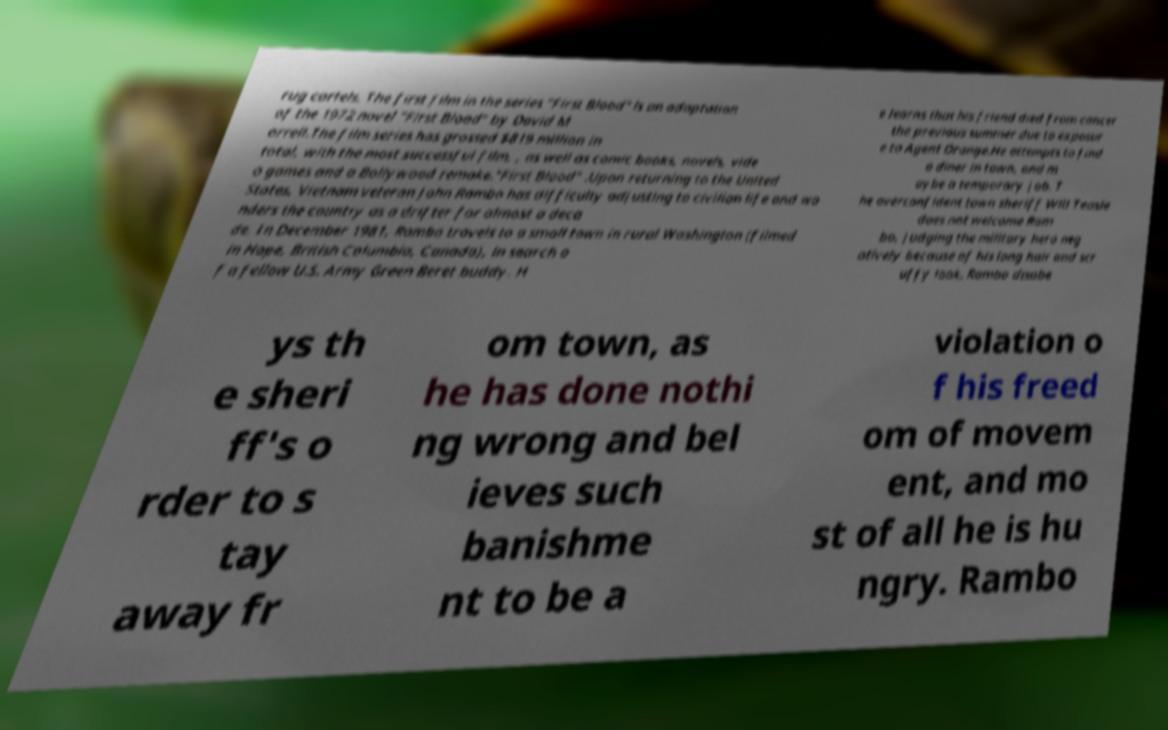I need the written content from this picture converted into text. Can you do that? rug cartels. The first film in the series "First Blood" is an adaptation of the 1972 novel "First Blood" by David M orrell.The film series has grossed $819 million in total, with the most successful film, , as well as comic books, novels, vide o games and a Bollywood remake."First Blood" .Upon returning to the United States, Vietnam veteran John Rambo has difficulty adjusting to civilian life and wa nders the country as a drifter for almost a deca de. In December 1981, Rambo travels to a small town in rural Washington (filmed in Hope, British Columbia, Canada), in search o f a fellow U.S. Army Green Beret buddy. H e learns that his friend died from cancer the previous summer due to exposur e to Agent Orange.He attempts to find a diner in town, and m aybe a temporary job. T he overconfident town sheriff Will Teasle does not welcome Ram bo, judging the military hero neg atively because of his long hair and scr uffy look. Rambo disobe ys th e sheri ff's o rder to s tay away fr om town, as he has done nothi ng wrong and bel ieves such banishme nt to be a violation o f his freed om of movem ent, and mo st of all he is hu ngry. Rambo 